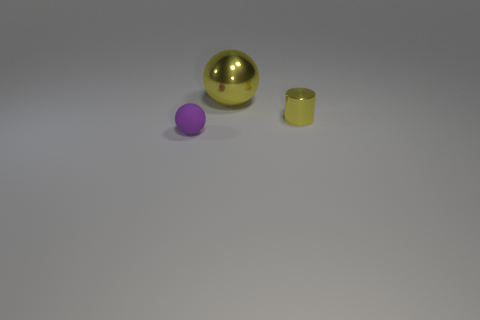Add 1 small objects. How many objects exist? 4 Subtract all big yellow metal things. Subtract all gray metal cylinders. How many objects are left? 2 Add 3 yellow shiny cylinders. How many yellow shiny cylinders are left? 4 Add 2 tiny purple balls. How many tiny purple balls exist? 3 Subtract 0 red cylinders. How many objects are left? 3 Subtract all balls. How many objects are left? 1 